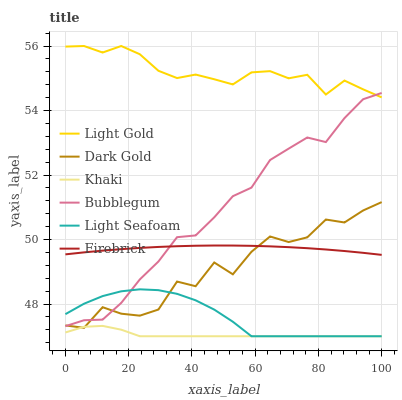Does Khaki have the minimum area under the curve?
Answer yes or no. Yes. Does Light Gold have the maximum area under the curve?
Answer yes or no. Yes. Does Dark Gold have the minimum area under the curve?
Answer yes or no. No. Does Dark Gold have the maximum area under the curve?
Answer yes or no. No. Is Firebrick the smoothest?
Answer yes or no. Yes. Is Dark Gold the roughest?
Answer yes or no. Yes. Is Dark Gold the smoothest?
Answer yes or no. No. Is Firebrick the roughest?
Answer yes or no. No. Does Khaki have the lowest value?
Answer yes or no. Yes. Does Dark Gold have the lowest value?
Answer yes or no. No. Does Light Gold have the highest value?
Answer yes or no. Yes. Does Dark Gold have the highest value?
Answer yes or no. No. Is Dark Gold less than Light Gold?
Answer yes or no. Yes. Is Light Gold greater than Khaki?
Answer yes or no. Yes. Does Light Seafoam intersect Khaki?
Answer yes or no. Yes. Is Light Seafoam less than Khaki?
Answer yes or no. No. Is Light Seafoam greater than Khaki?
Answer yes or no. No. Does Dark Gold intersect Light Gold?
Answer yes or no. No. 